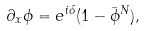Convert formula to latex. <formula><loc_0><loc_0><loc_500><loc_500>\partial _ { x } \phi = e ^ { i \delta } ( 1 - \bar { \phi } ^ { N } ) ,</formula> 